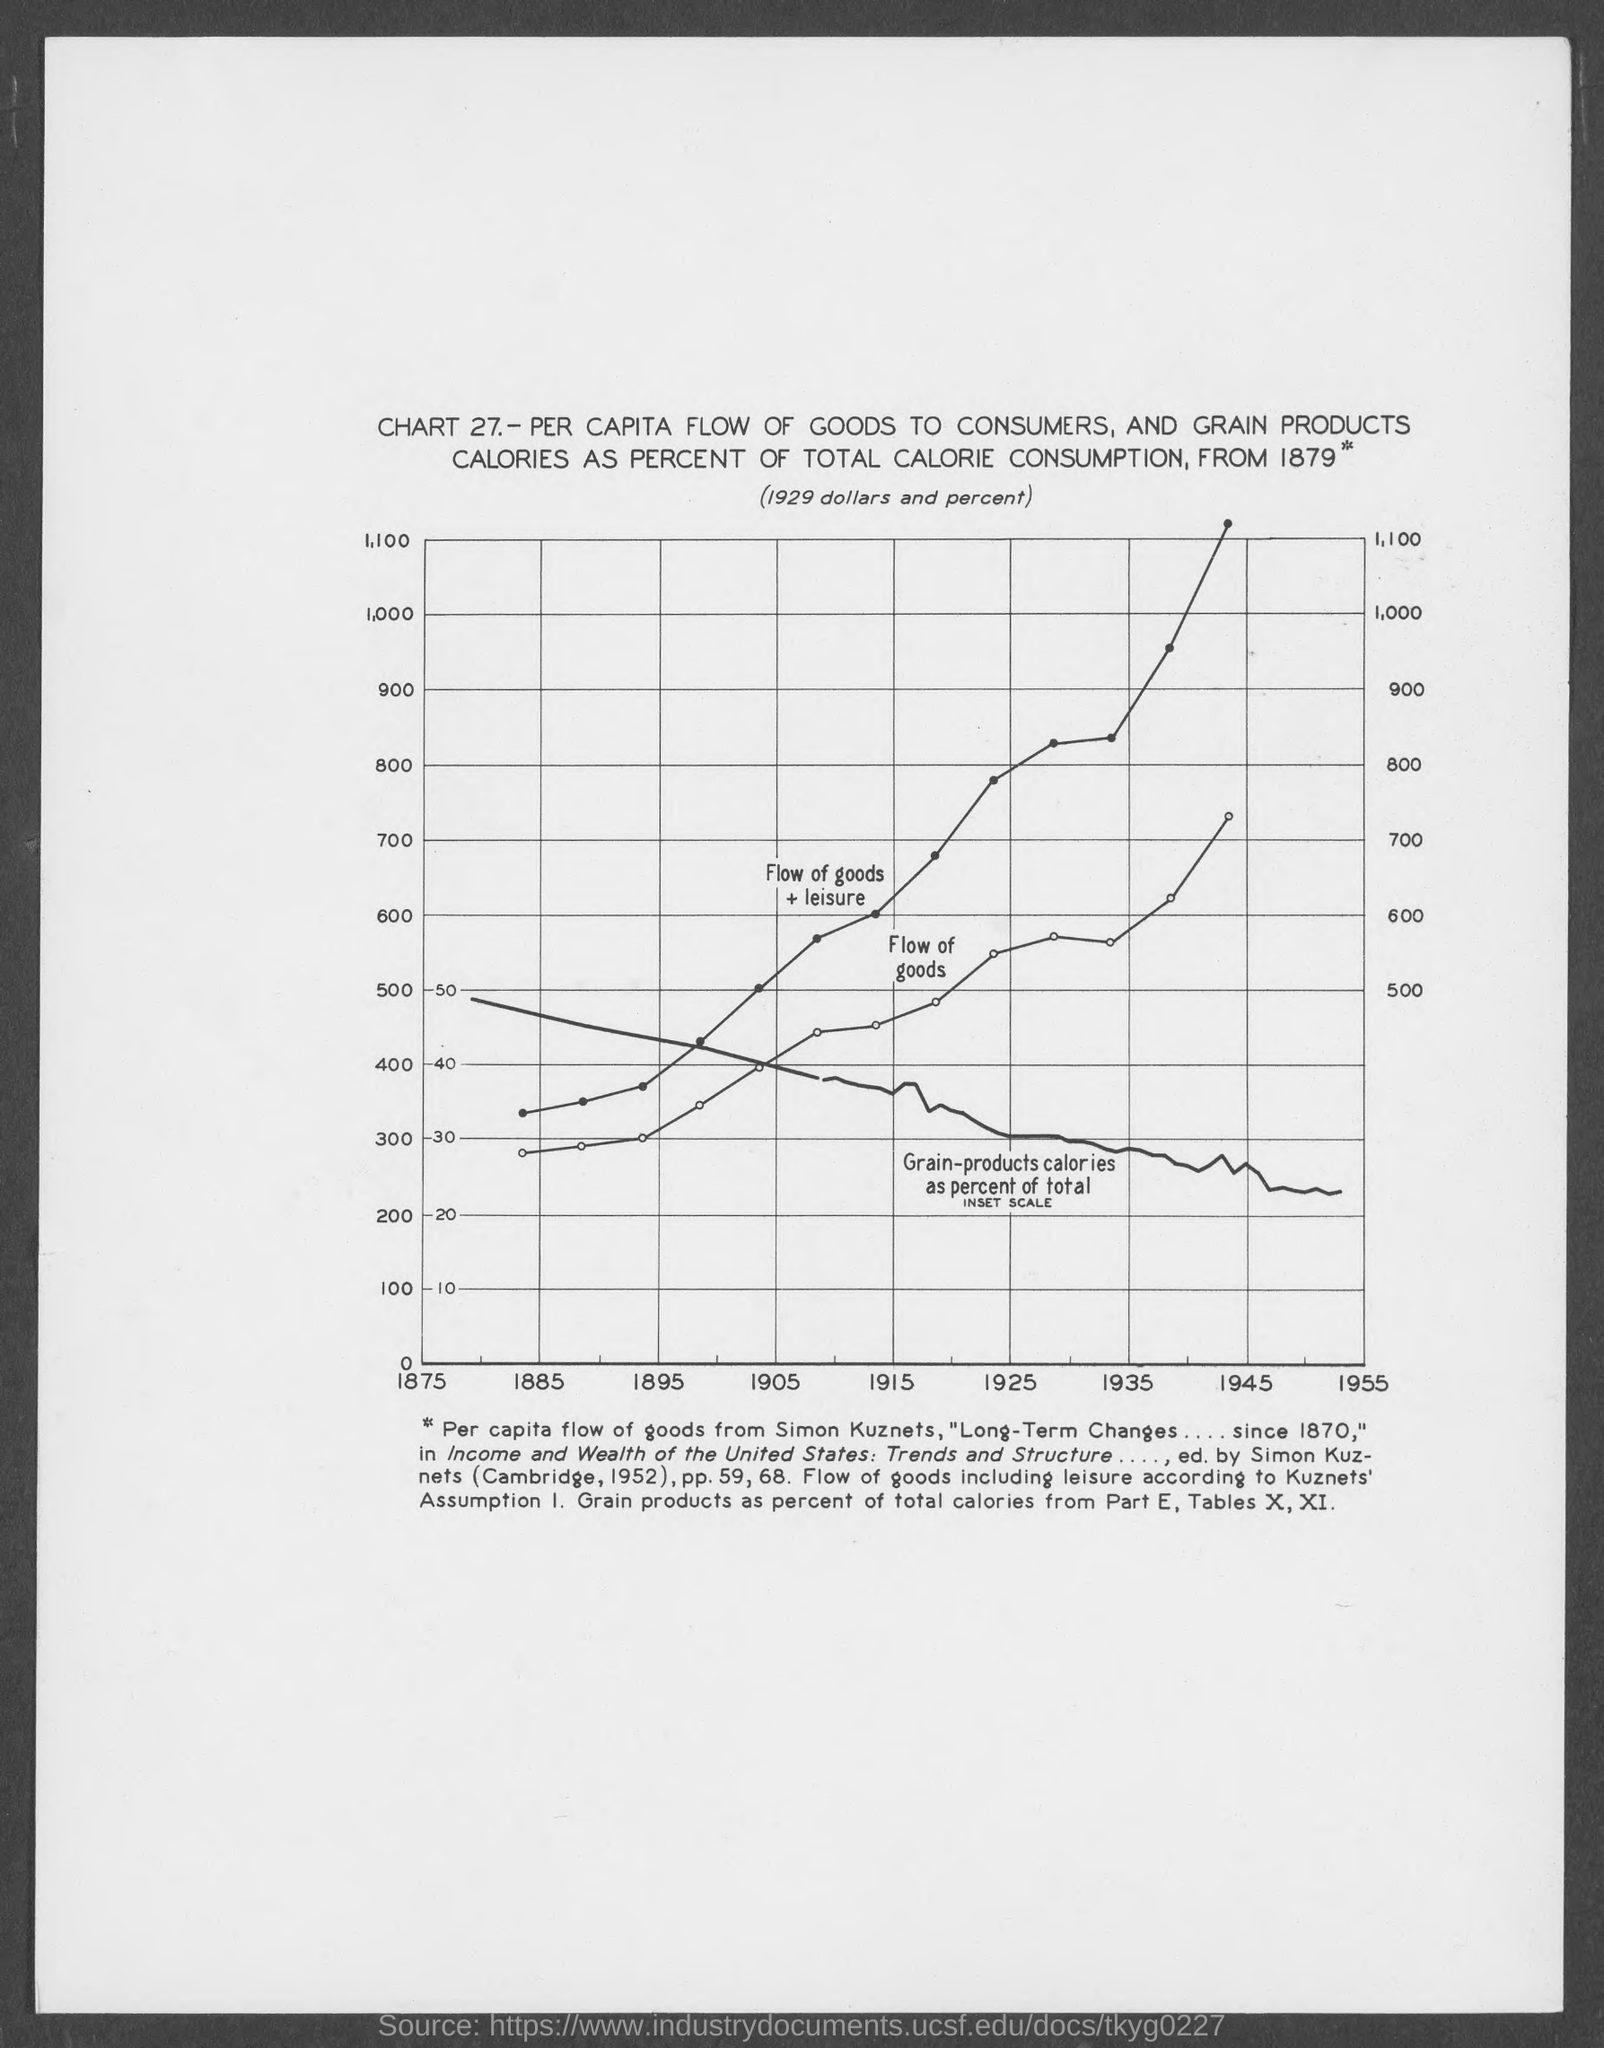Draw attention to some important aspects in this diagram. This chart shows the per capita flow of goods to consumers and the percentage of total calorie consumption from grain products from 1879 to the present. The chart number is unknown. It is referred to as "Chart 27". The year that is mentioned first on the x-axis is 1875. 